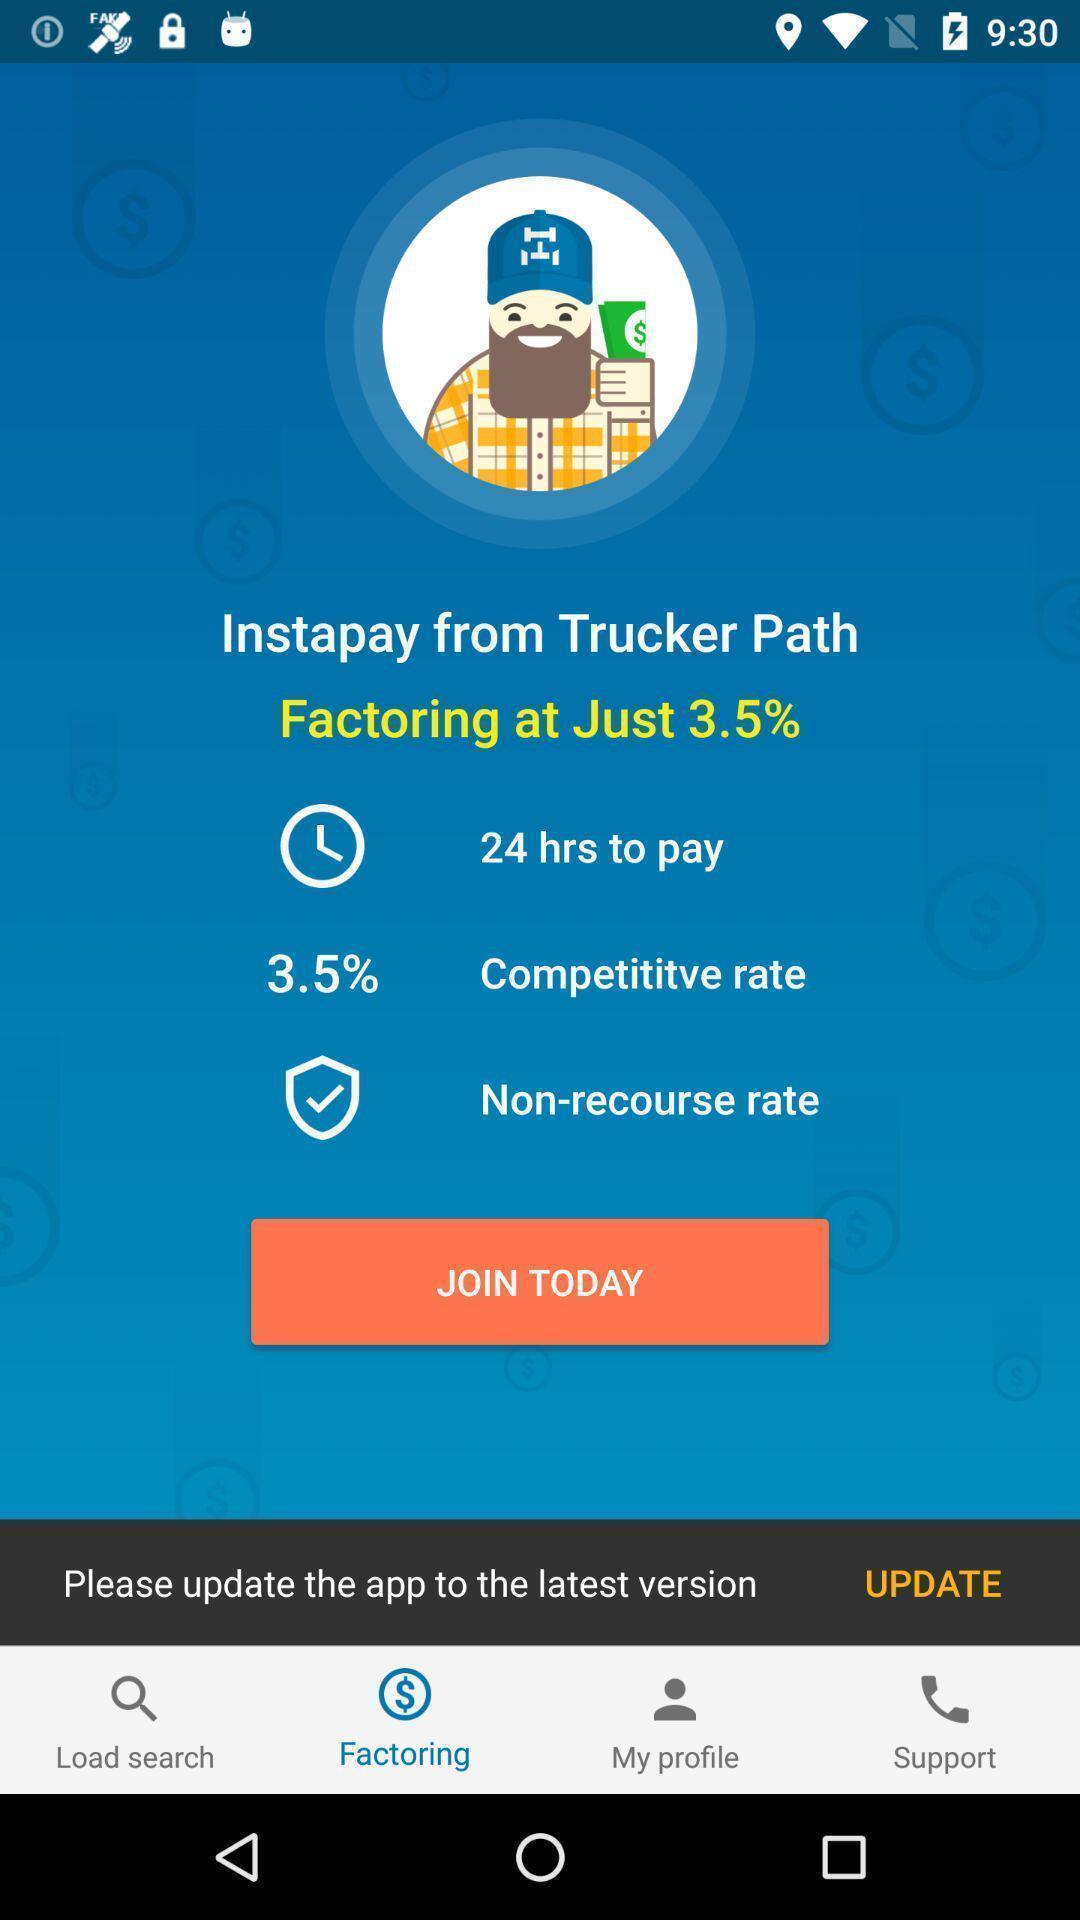Explain the elements present in this screenshot. Page showing different options in a banking app. 